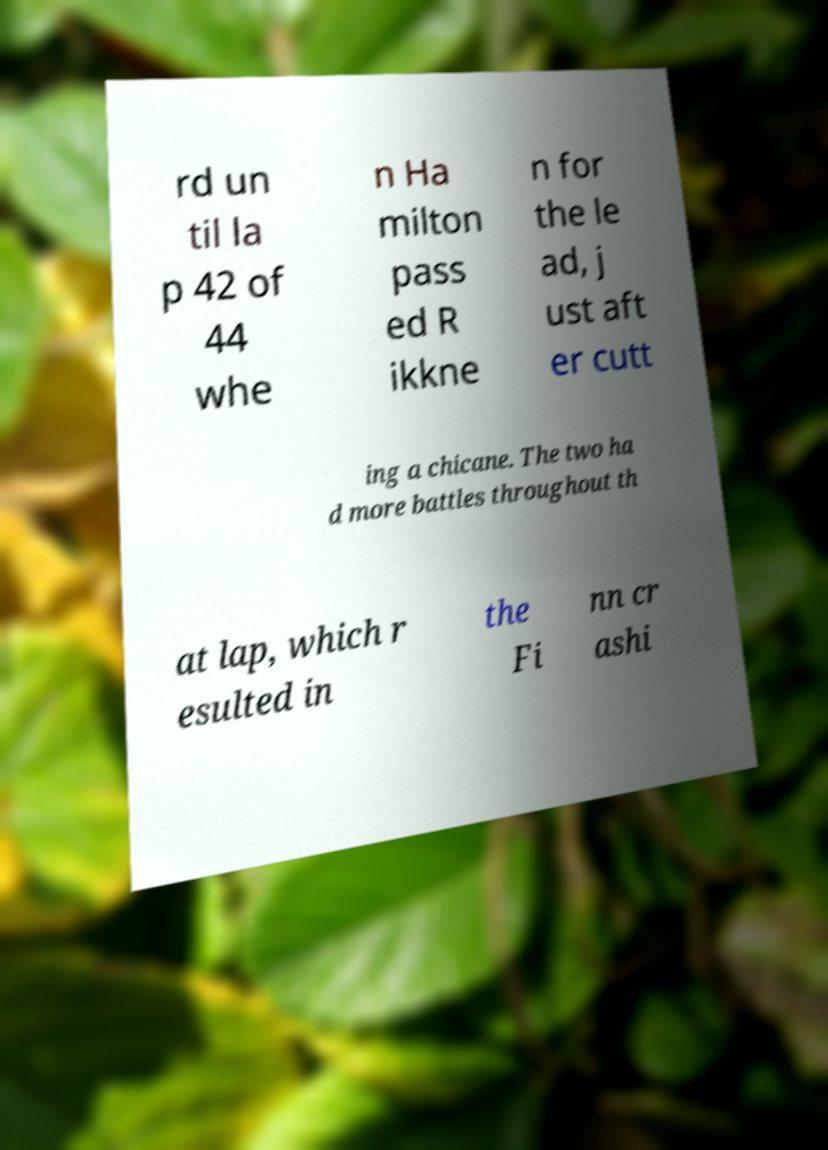Please identify and transcribe the text found in this image. rd un til la p 42 of 44 whe n Ha milton pass ed R ikkne n for the le ad, j ust aft er cutt ing a chicane. The two ha d more battles throughout th at lap, which r esulted in the Fi nn cr ashi 